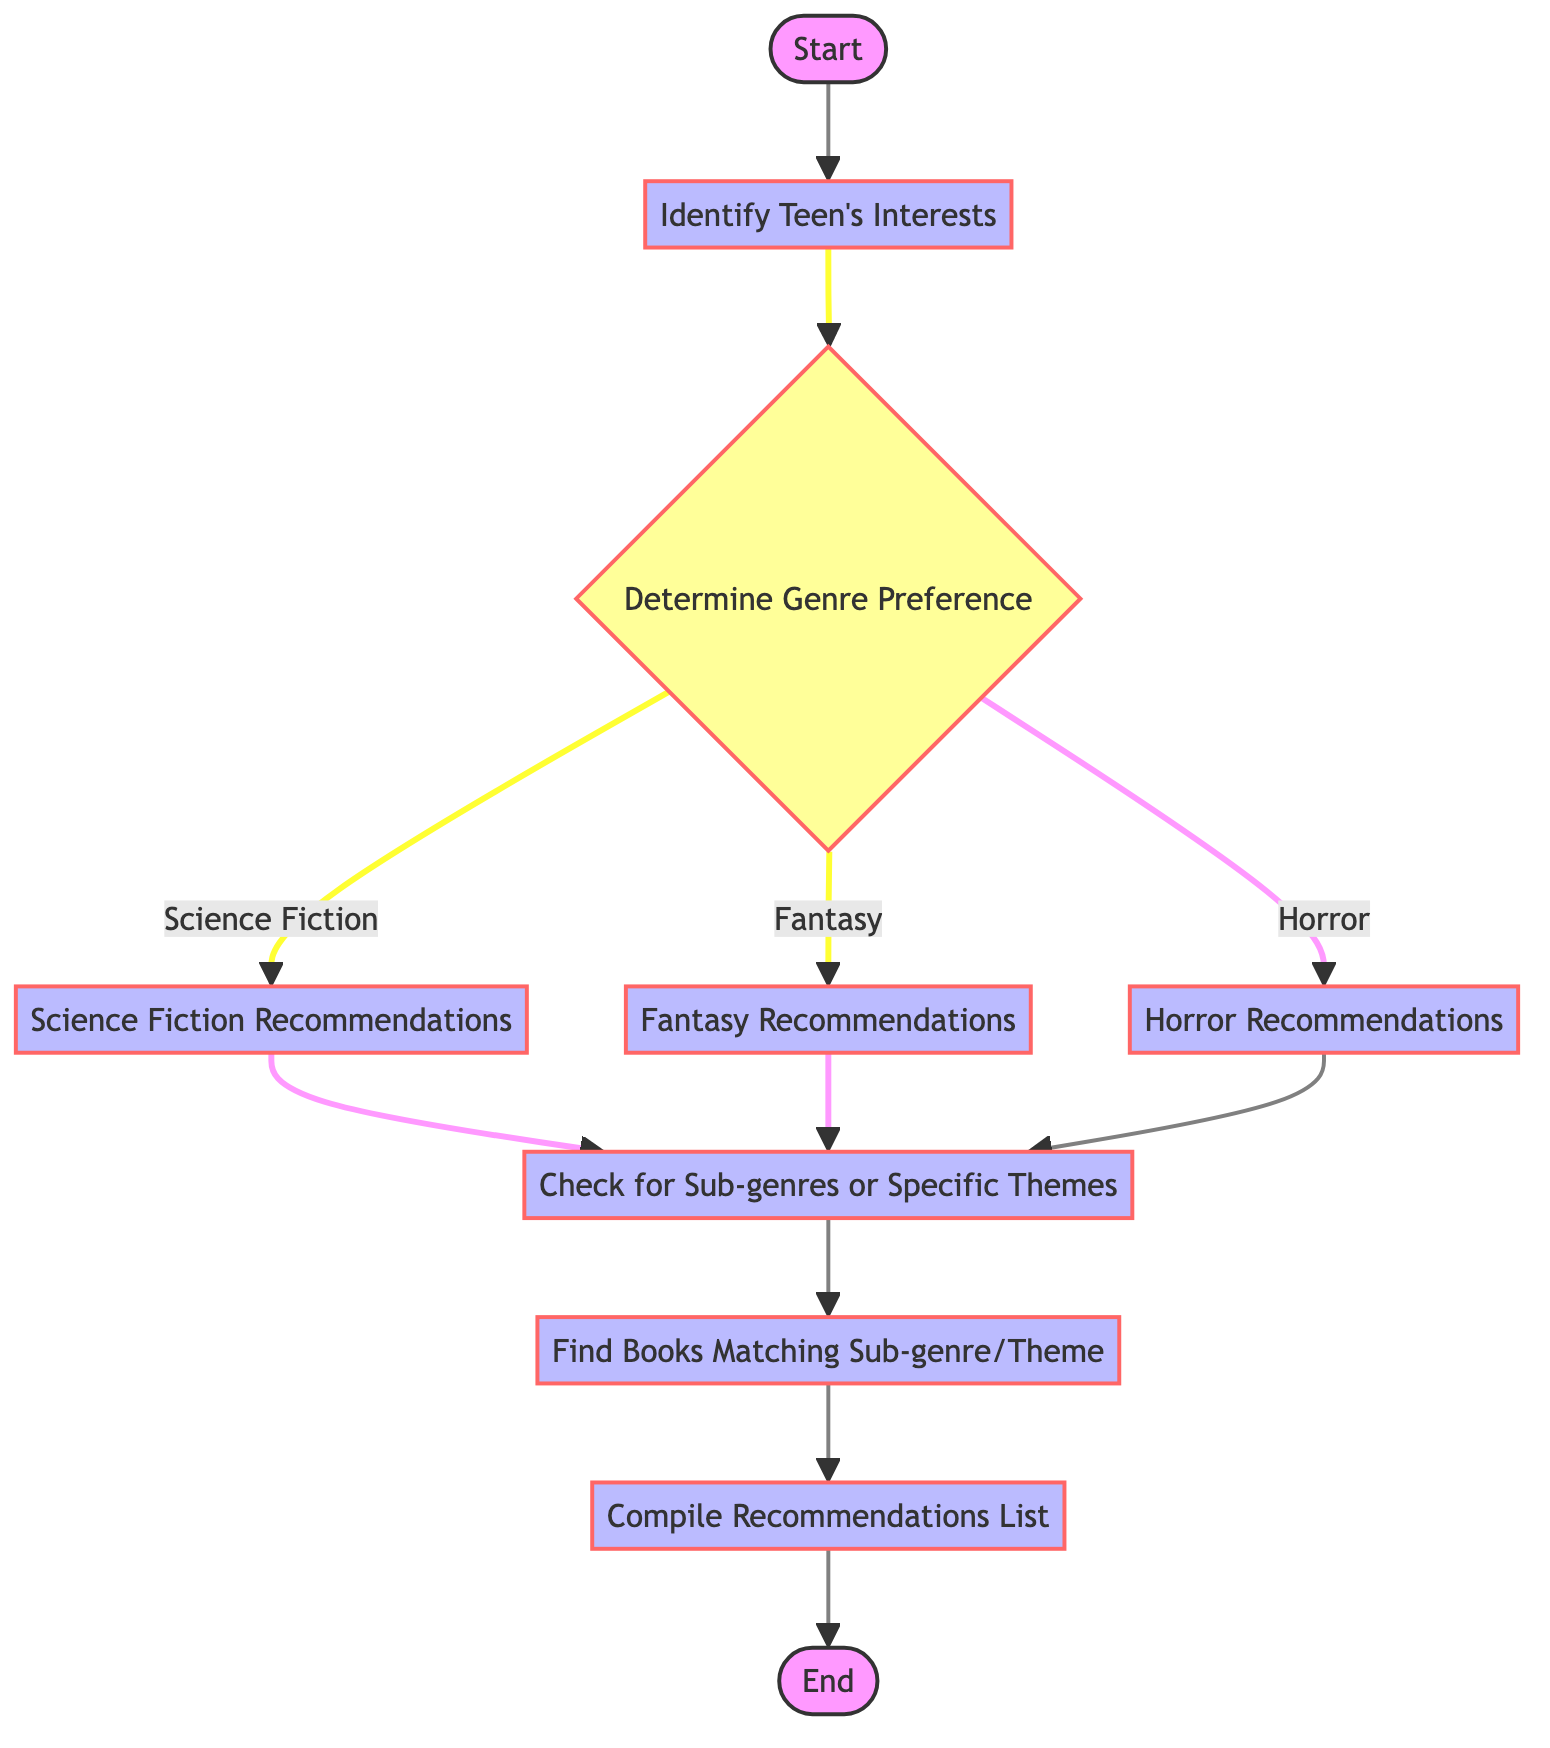What is the first step in recommending books? The first step is "Start", which indicates the beginning of the process for recommending speculative fiction books to teens.
Answer: Start How many types of preferences are determined in the decision node? There are three types of genre preferences identified in the decision node: Science Fiction, Fantasy, and Horror.
Answer: 3 What happens after you identify the teen's interests? After identifying the teen's interests, the next step is to determine their genre preference. This involves deciding between Science Fiction, Fantasy, or Horror.
Answer: Determine Genre Preference Which node provides recommendations for Horror? The node that provides recommendations for Horror is labeled "Horror Recommendations".
Answer: Horror Recommendations What do you do after compiling the recommendations list? After compiling the recommendations list, the process ends at the "End" node, indicating the conclusion of the recommendation process.
Answer: End If a teen prefers Fantasy, where is the next step after that? If a teen prefers Fantasy, the next step is to proceed to "Check for Sub-genres or Specific Themes". This connects directly from the Fantasy preferences node.
Answer: Check for Sub-genres or Specific Themes What is the ultimate outcome of this flow chart? The ultimate outcome of this flow chart is to compile a recommendations list, leading to the "End" node, indicating successful completion of the book recommendation process.
Answer: Compile Recommendations List What is necessary before finding books that match sub-genres or themes? Before finding books that match sub-genres or themes, it is necessary to check for sub-genres or specific themes that the teen is interested in.
Answer: Check for Sub-genres or Specific Themes 